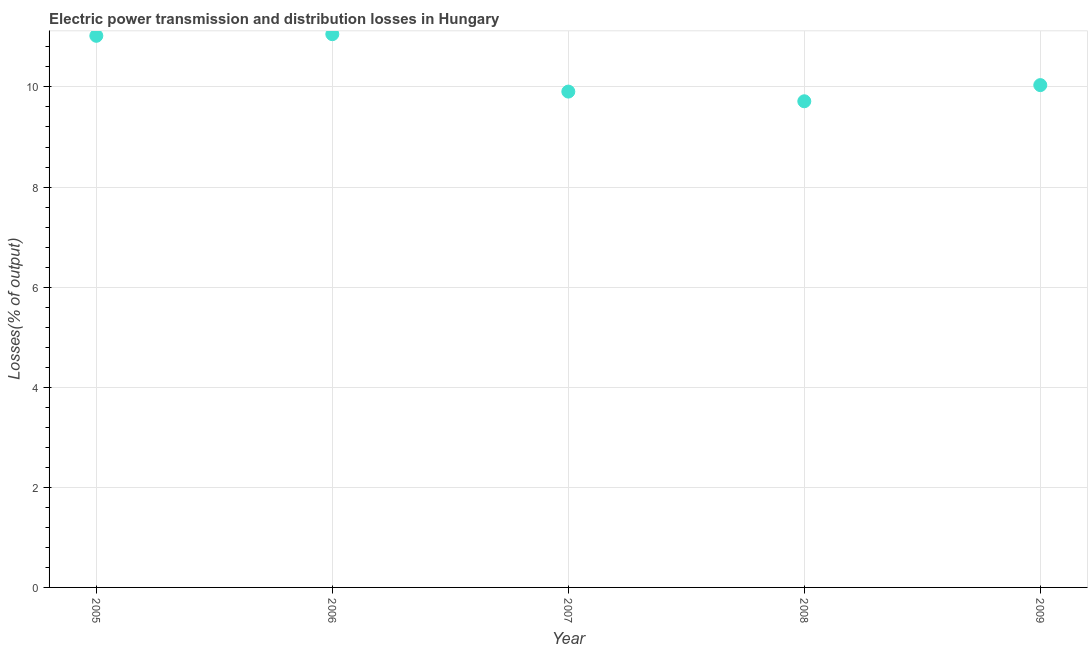What is the electric power transmission and distribution losses in 2006?
Keep it short and to the point. 11.05. Across all years, what is the maximum electric power transmission and distribution losses?
Keep it short and to the point. 11.05. Across all years, what is the minimum electric power transmission and distribution losses?
Make the answer very short. 9.71. In which year was the electric power transmission and distribution losses maximum?
Your answer should be very brief. 2006. In which year was the electric power transmission and distribution losses minimum?
Your response must be concise. 2008. What is the sum of the electric power transmission and distribution losses?
Your answer should be very brief. 51.73. What is the difference between the electric power transmission and distribution losses in 2005 and 2006?
Provide a succinct answer. -0.03. What is the average electric power transmission and distribution losses per year?
Make the answer very short. 10.35. What is the median electric power transmission and distribution losses?
Your response must be concise. 10.04. What is the ratio of the electric power transmission and distribution losses in 2005 to that in 2006?
Your answer should be very brief. 1. Is the electric power transmission and distribution losses in 2007 less than that in 2009?
Your answer should be very brief. Yes. Is the difference between the electric power transmission and distribution losses in 2005 and 2006 greater than the difference between any two years?
Your response must be concise. No. What is the difference between the highest and the second highest electric power transmission and distribution losses?
Make the answer very short. 0.03. Is the sum of the electric power transmission and distribution losses in 2005 and 2009 greater than the maximum electric power transmission and distribution losses across all years?
Offer a very short reply. Yes. What is the difference between the highest and the lowest electric power transmission and distribution losses?
Offer a terse response. 1.34. Does the electric power transmission and distribution losses monotonically increase over the years?
Your answer should be very brief. No. What is the difference between two consecutive major ticks on the Y-axis?
Your answer should be compact. 2. Does the graph contain any zero values?
Provide a succinct answer. No. What is the title of the graph?
Ensure brevity in your answer.  Electric power transmission and distribution losses in Hungary. What is the label or title of the X-axis?
Make the answer very short. Year. What is the label or title of the Y-axis?
Ensure brevity in your answer.  Losses(% of output). What is the Losses(% of output) in 2005?
Provide a short and direct response. 11.02. What is the Losses(% of output) in 2006?
Your answer should be compact. 11.05. What is the Losses(% of output) in 2007?
Keep it short and to the point. 9.91. What is the Losses(% of output) in 2008?
Offer a terse response. 9.71. What is the Losses(% of output) in 2009?
Your response must be concise. 10.04. What is the difference between the Losses(% of output) in 2005 and 2006?
Provide a short and direct response. -0.03. What is the difference between the Losses(% of output) in 2005 and 2007?
Your answer should be very brief. 1.11. What is the difference between the Losses(% of output) in 2005 and 2008?
Your answer should be compact. 1.31. What is the difference between the Losses(% of output) in 2005 and 2009?
Offer a very short reply. 0.99. What is the difference between the Losses(% of output) in 2006 and 2007?
Your response must be concise. 1.15. What is the difference between the Losses(% of output) in 2006 and 2008?
Ensure brevity in your answer.  1.34. What is the difference between the Losses(% of output) in 2006 and 2009?
Your answer should be compact. 1.02. What is the difference between the Losses(% of output) in 2007 and 2008?
Give a very brief answer. 0.19. What is the difference between the Losses(% of output) in 2007 and 2009?
Make the answer very short. -0.13. What is the difference between the Losses(% of output) in 2008 and 2009?
Provide a succinct answer. -0.32. What is the ratio of the Losses(% of output) in 2005 to that in 2007?
Keep it short and to the point. 1.11. What is the ratio of the Losses(% of output) in 2005 to that in 2008?
Offer a terse response. 1.14. What is the ratio of the Losses(% of output) in 2005 to that in 2009?
Give a very brief answer. 1.1. What is the ratio of the Losses(% of output) in 2006 to that in 2007?
Provide a short and direct response. 1.12. What is the ratio of the Losses(% of output) in 2006 to that in 2008?
Offer a very short reply. 1.14. What is the ratio of the Losses(% of output) in 2006 to that in 2009?
Ensure brevity in your answer.  1.1. What is the ratio of the Losses(% of output) in 2007 to that in 2009?
Make the answer very short. 0.99. 